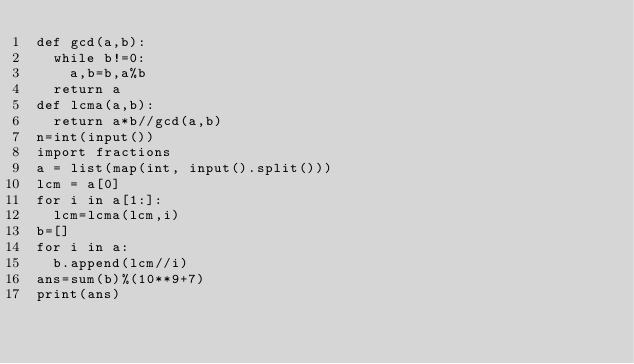Convert code to text. <code><loc_0><loc_0><loc_500><loc_500><_Python_>def gcd(a,b):
  while b!=0:
    a,b=b,a%b
  return a
def lcma(a,b):
  return a*b//gcd(a,b)
n=int(input())
import fractions
a = list(map(int, input().split()))
lcm = a[0]
for i in a[1:]:
  lcm=lcma(lcm,i)
b=[]
for i in a:
  b.append(lcm//i)
ans=sum(b)%(10**9+7)
print(ans)</code> 